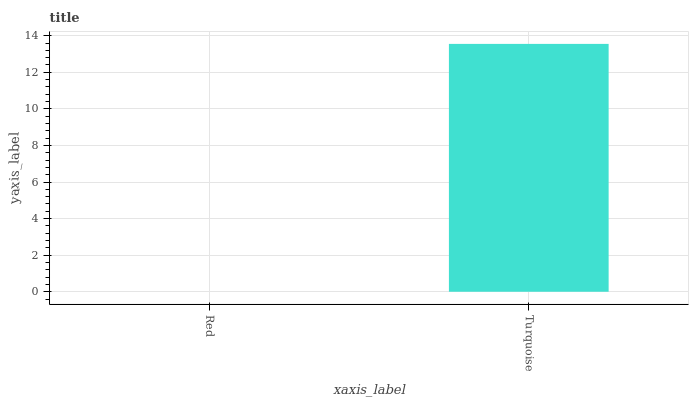Is Turquoise the minimum?
Answer yes or no. No. Is Turquoise greater than Red?
Answer yes or no. Yes. Is Red less than Turquoise?
Answer yes or no. Yes. Is Red greater than Turquoise?
Answer yes or no. No. Is Turquoise less than Red?
Answer yes or no. No. Is Turquoise the high median?
Answer yes or no. Yes. Is Red the low median?
Answer yes or no. Yes. Is Red the high median?
Answer yes or no. No. Is Turquoise the low median?
Answer yes or no. No. 